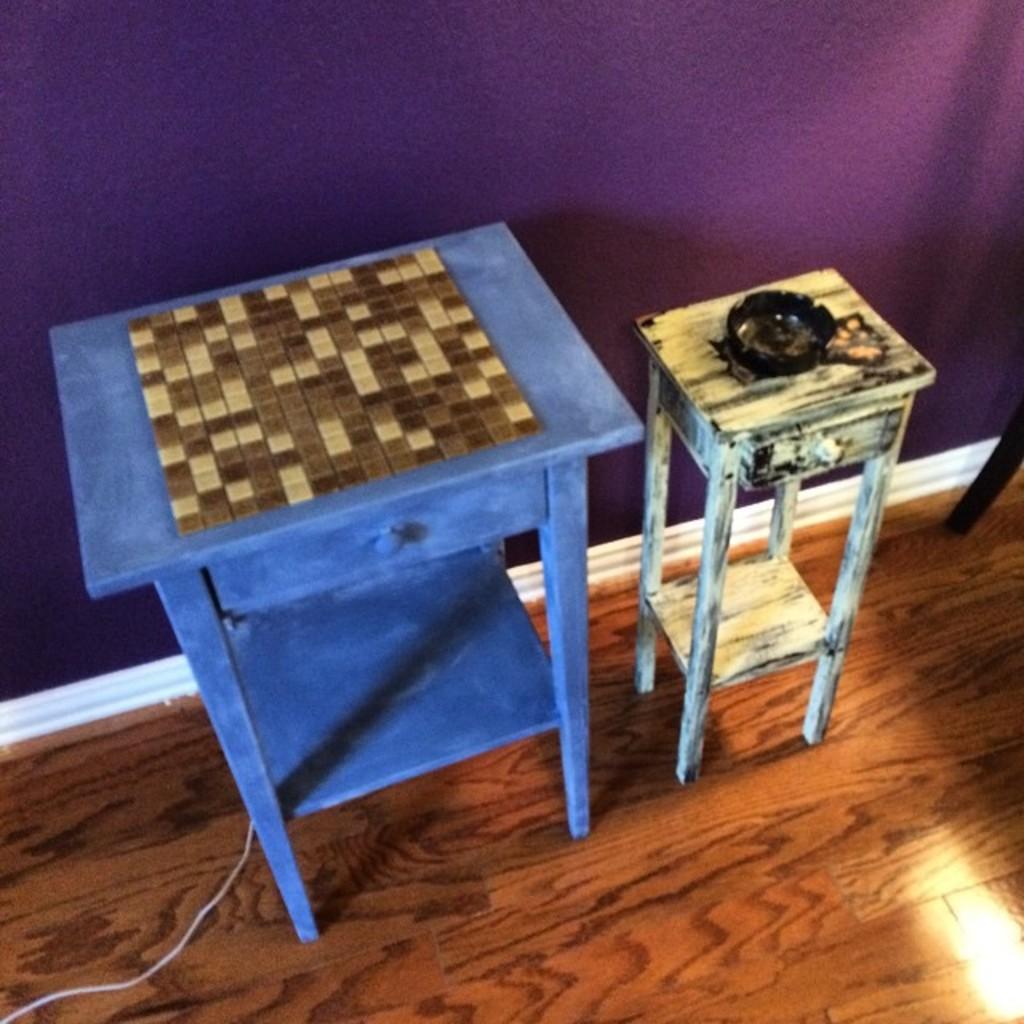Please provide a concise description of this image. In this image we can see a table and a stool placed on the wooden floor. We can also see a wall and a wire. 